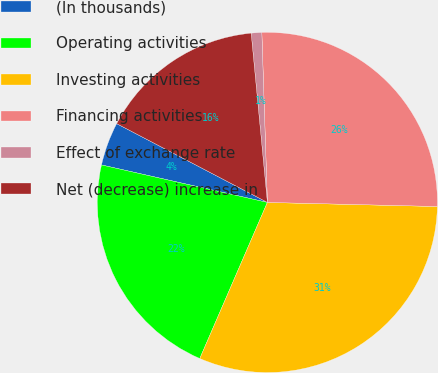Convert chart. <chart><loc_0><loc_0><loc_500><loc_500><pie_chart><fcel>(In thousands)<fcel>Operating activities<fcel>Investing activities<fcel>Financing activities<fcel>Effect of exchange rate<fcel>Net (decrease) increase in<nl><fcel>4.13%<fcel>22.03%<fcel>31.12%<fcel>25.9%<fcel>1.0%<fcel>15.81%<nl></chart> 